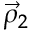Convert formula to latex. <formula><loc_0><loc_0><loc_500><loc_500>\vec { \rho } _ { 2 }</formula> 